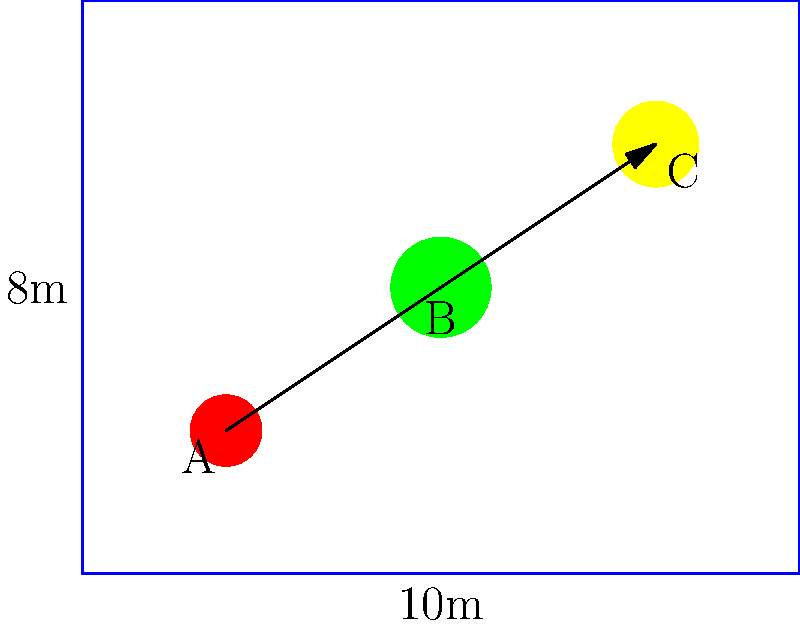Given the factory floor layout shown in the diagram, where machines A, B, and C are represented by circles and the workflow is indicated by arrows, calculate the total distance traveled by a product moving through the production line. Assume that the factory floor dimensions are 10m x 8m and that the machines are located at the centers of their respective circles. Round your answer to the nearest meter. To solve this problem, we need to follow these steps:

1. Determine the coordinates of each machine:
   Machine A: (2, 2)
   Machine B: (5, 4)
   Machine C: (8, 6)

2. Calculate the distance between machines A and B:
   $$ d_{AB} = \sqrt{(x_B - x_A)^2 + (y_B - y_A)^2} $$
   $$ d_{AB} = \sqrt{(5 - 2)^2 + (4 - 2)^2} = \sqrt{9 + 4} = \sqrt{13} \approx 3.61 \text{ m} $$

3. Calculate the distance between machines B and C:
   $$ d_{BC} = \sqrt{(x_C - x_B)^2 + (y_C - y_B)^2} $$
   $$ d_{BC} = \sqrt{(8 - 5)^2 + (6 - 4)^2} = \sqrt{9 + 4} = \sqrt{13} \approx 3.61 \text{ m} $$

4. Sum up the total distance:
   Total distance = $d_{AB} + d_{BC} = 3.61 + 3.61 = 7.22 \text{ m}$

5. Round to the nearest meter:
   7.22 m rounds to 7 m

Therefore, the total distance traveled by a product moving through the production line is approximately 7 meters.
Answer: 7 m 